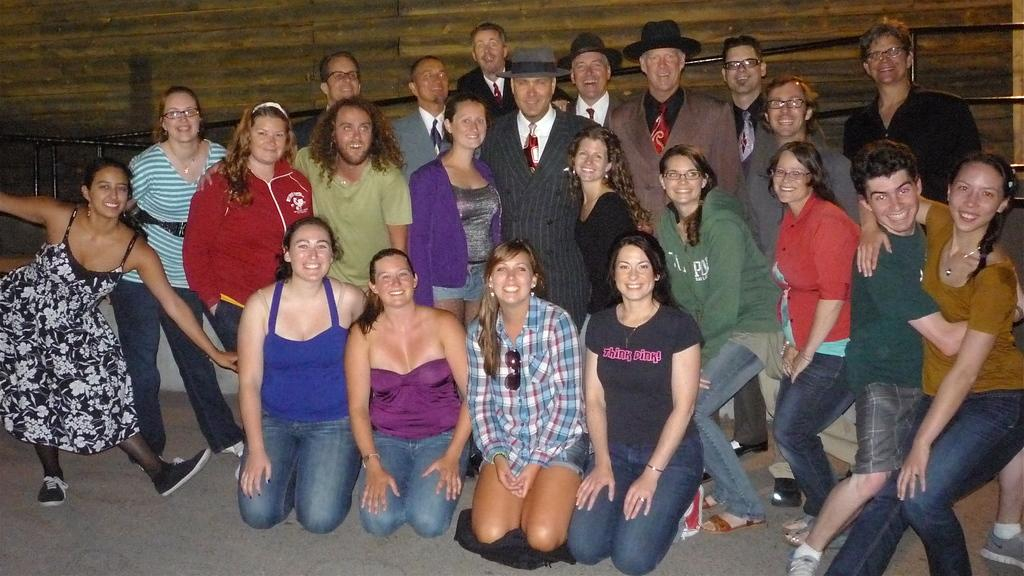What is the main subject of the image? The main subject of the image is a group of people. How are the people in the image feeling? The people in the image have smiles on their faces, which suggests they are happy or enjoying themselves. What positions are the people in the image taking? Some people are seated, while others are standing. What type of seed can be seen growing in the image? There is no seed present in the image; it features a group of people. What kind of bone is visible in the image? There is no bone present in the image; it features a group of people. 